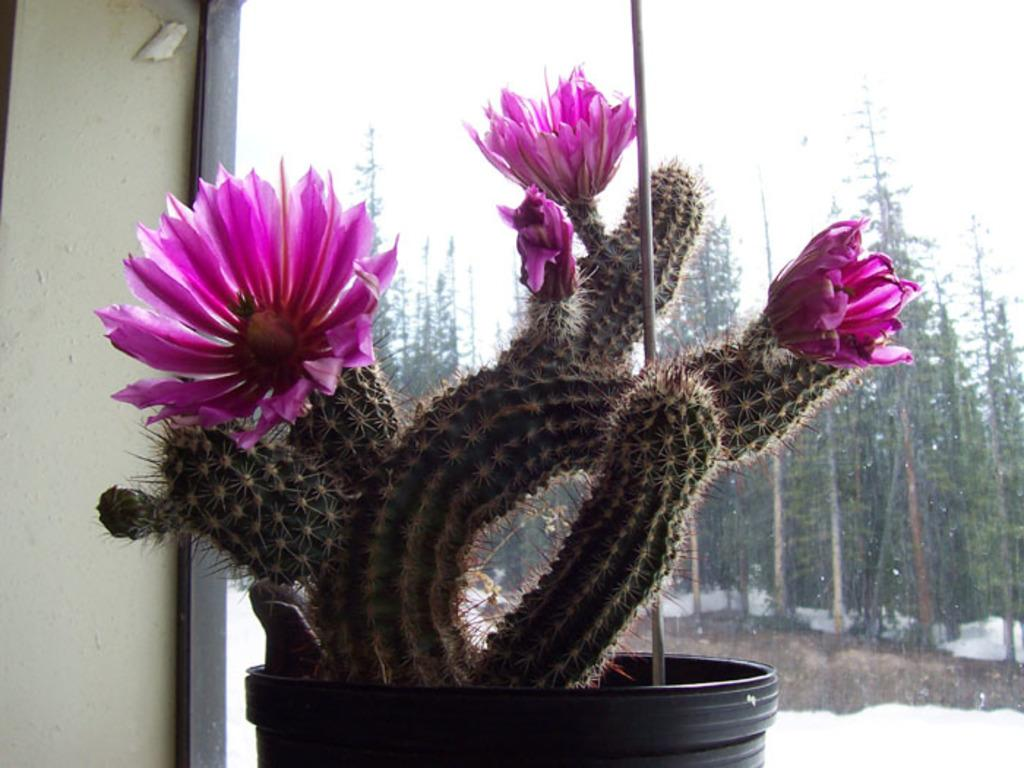What type of plant is featured in the image? There is a cactus plant with pink flowers in the image. How is the cactus plant contained? The cactus plant is in a black pot. What is the small pole near the cactus plant used for? The purpose of the small pole near the cactus plant is not specified in the image. What can be seen through the window in the image? Trees are visible through the window. What is the weather like outside the window? Snow is present on the ground outside the window, indicating cold weather. What type of cup is being used to water the cactus plant in the image? There is no cup visible in the image, and the cactus plant does not appear to be watered. What color are the socks being worn by the cactus plant in the image? The cactus plant is not a living being and does not wear socks. 